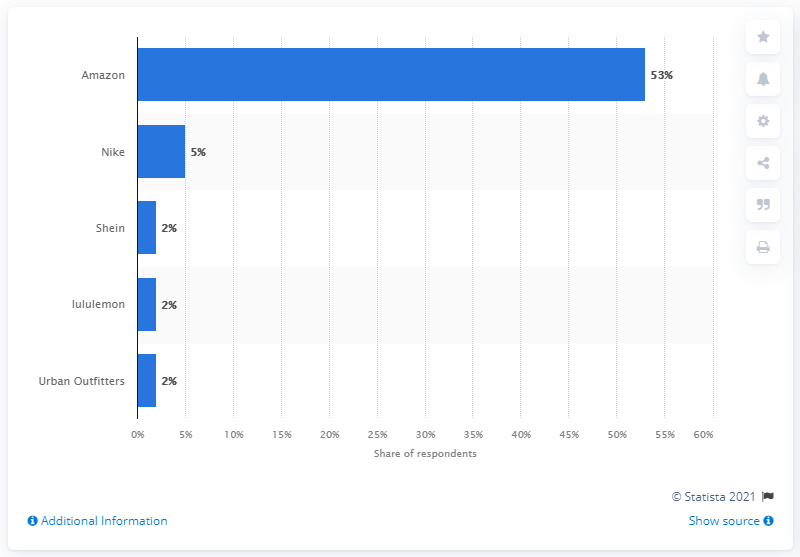List a handful of essential elements in this visual. According to the survey, Nike was ranked as the second best brand. Amazon was the most popular online shopping site among teenagers in the United States. 